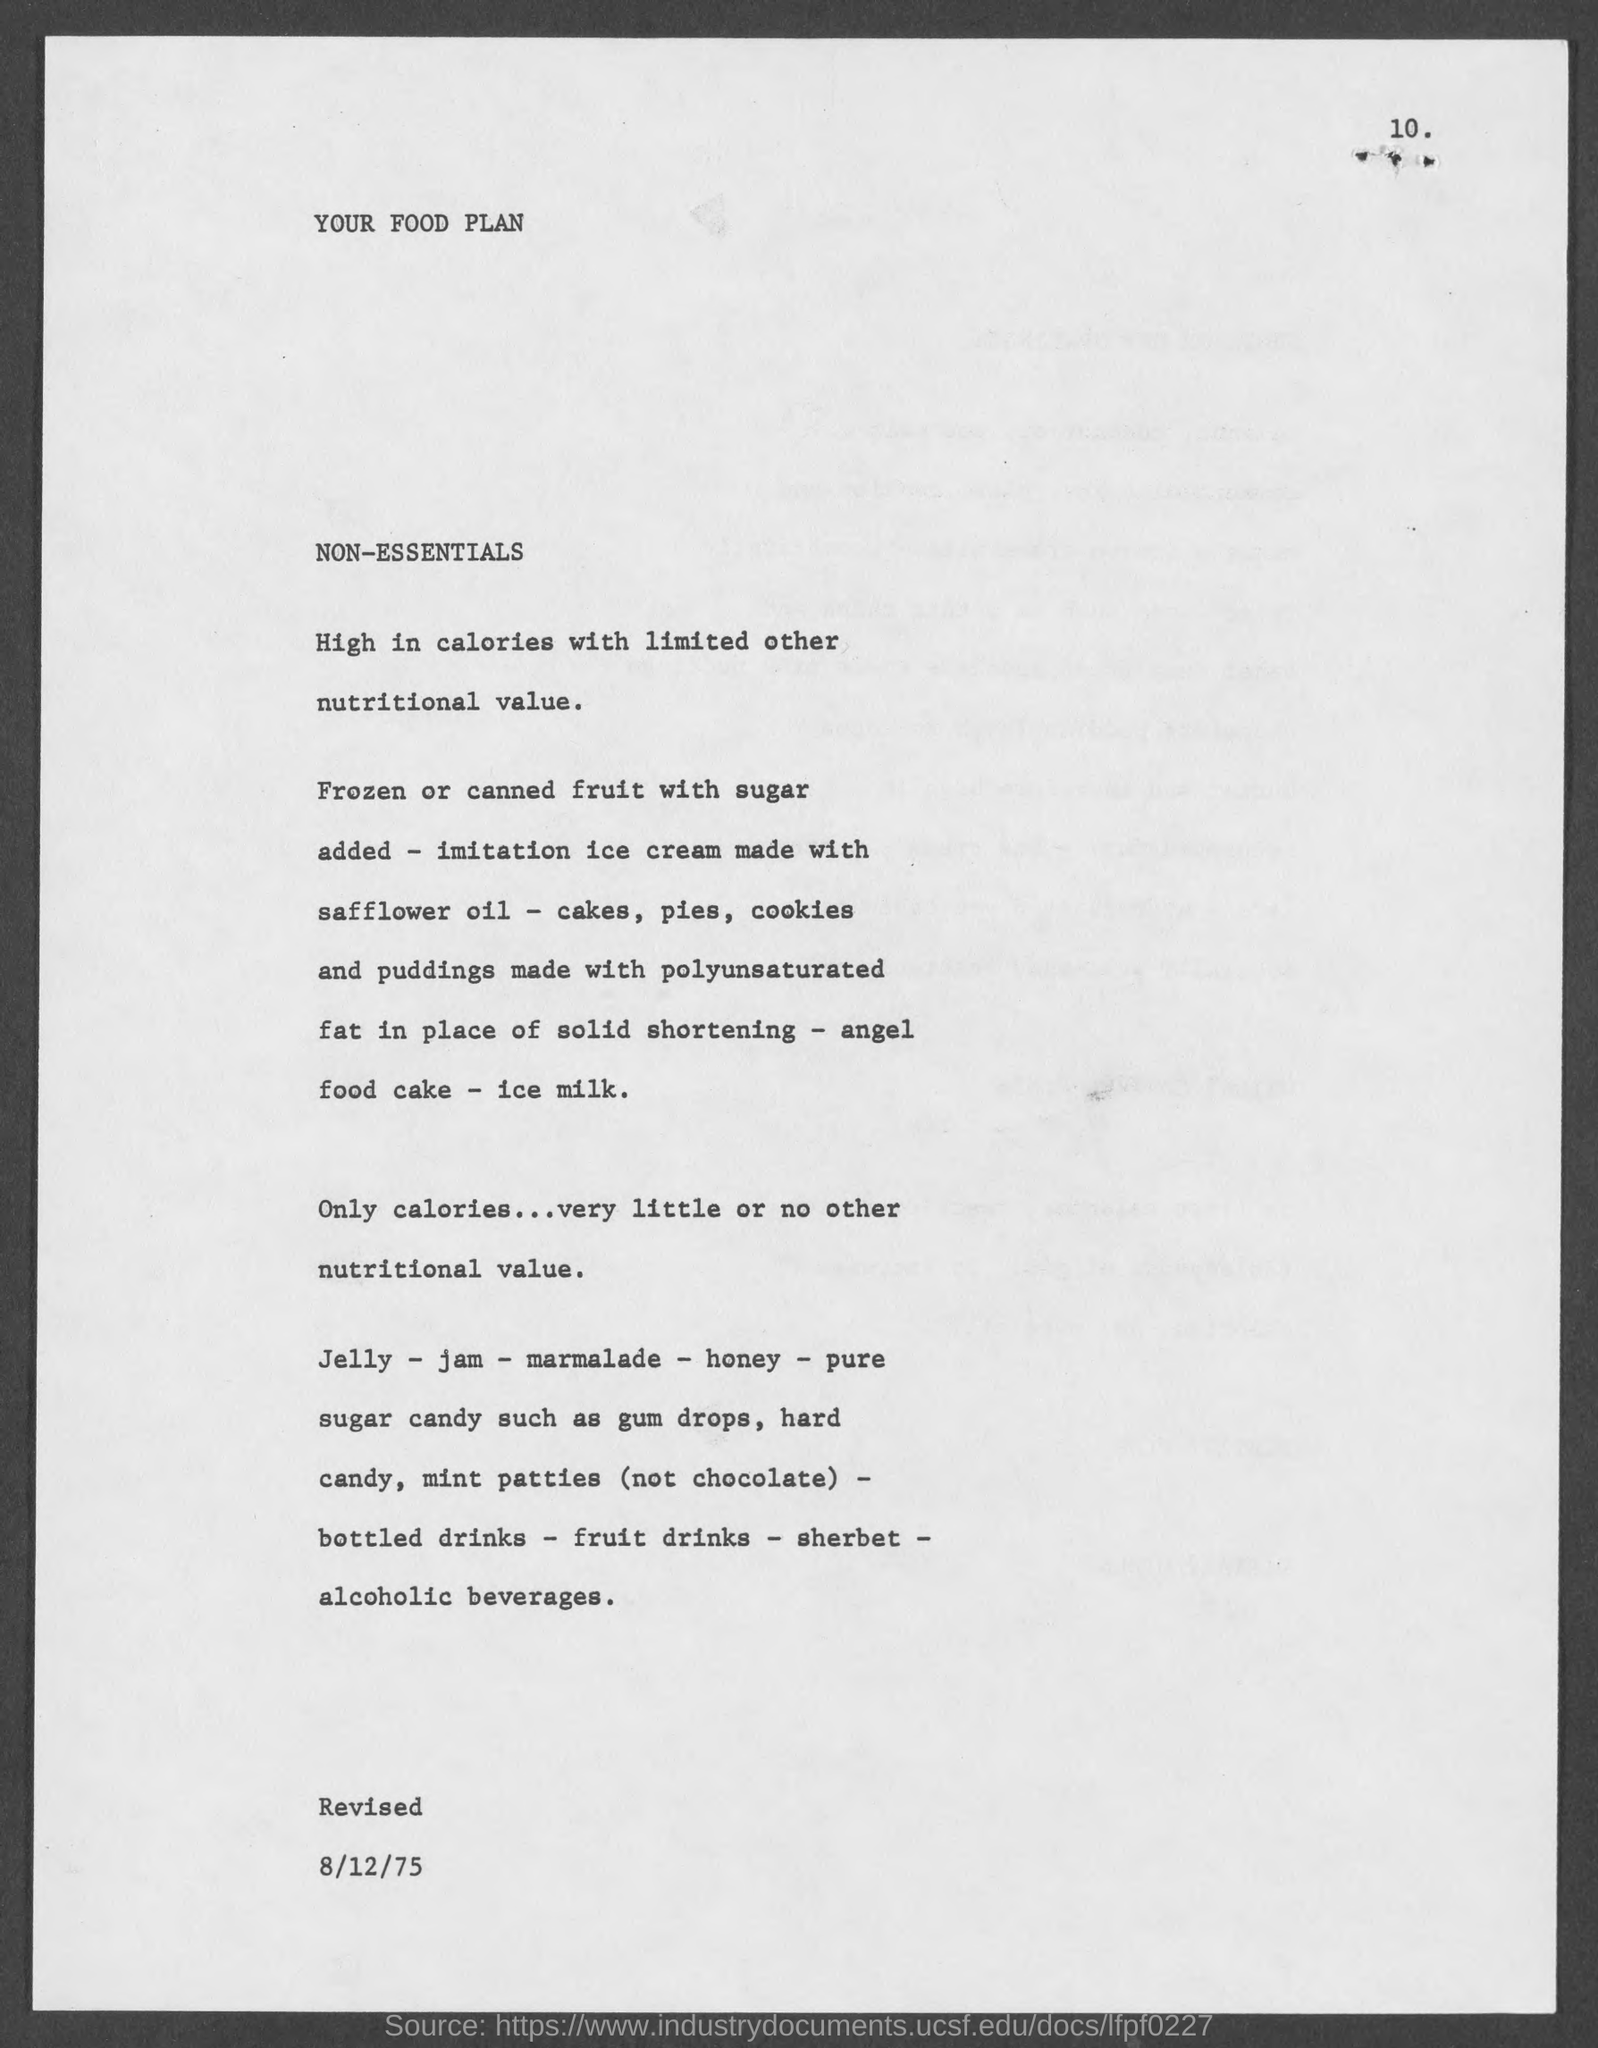What is the Title of the document?
Your answer should be compact. Your food plan. 